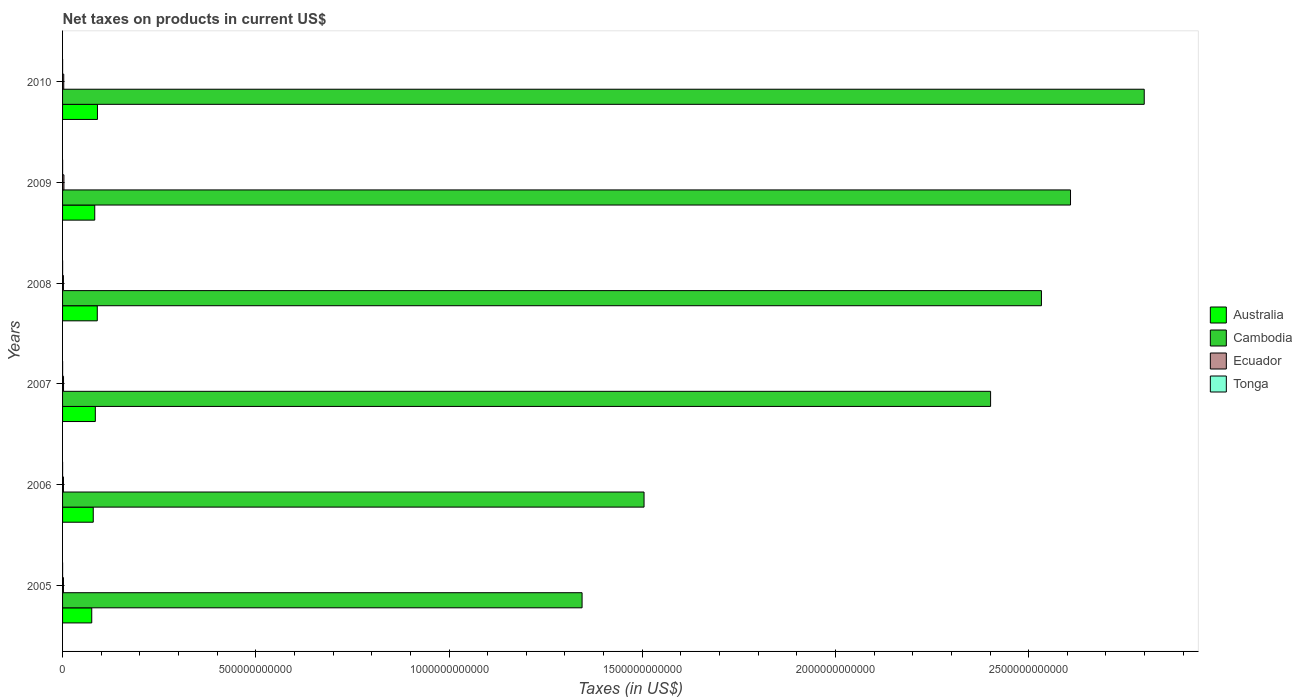How many different coloured bars are there?
Your response must be concise. 4. Are the number of bars per tick equal to the number of legend labels?
Make the answer very short. Yes. Are the number of bars on each tick of the Y-axis equal?
Your answer should be very brief. Yes. What is the label of the 4th group of bars from the top?
Your response must be concise. 2007. In how many cases, is the number of bars for a given year not equal to the number of legend labels?
Your answer should be very brief. 0. What is the net taxes on products in Tonga in 2010?
Keep it short and to the point. 8.43e+07. Across all years, what is the maximum net taxes on products in Tonga?
Give a very brief answer. 1.11e+08. Across all years, what is the minimum net taxes on products in Australia?
Keep it short and to the point. 7.55e+1. In which year was the net taxes on products in Australia maximum?
Your answer should be very brief. 2010. What is the total net taxes on products in Tonga in the graph?
Give a very brief answer. 5.38e+08. What is the difference between the net taxes on products in Ecuador in 2005 and that in 2010?
Provide a short and direct response. -7.54e+08. What is the difference between the net taxes on products in Tonga in 2005 and the net taxes on products in Cambodia in 2008?
Keep it short and to the point. -2.53e+12. What is the average net taxes on products in Tonga per year?
Your answer should be very brief. 8.97e+07. In the year 2009, what is the difference between the net taxes on products in Ecuador and net taxes on products in Tonga?
Make the answer very short. 3.42e+09. In how many years, is the net taxes on products in Tonga greater than 1100000000000 US$?
Your answer should be compact. 0. What is the ratio of the net taxes on products in Ecuador in 2009 to that in 2010?
Your answer should be compact. 1.15. Is the net taxes on products in Australia in 2005 less than that in 2010?
Your response must be concise. Yes. What is the difference between the highest and the second highest net taxes on products in Australia?
Ensure brevity in your answer.  4.98e+08. What is the difference between the highest and the lowest net taxes on products in Australia?
Ensure brevity in your answer.  1.48e+1. Is the sum of the net taxes on products in Australia in 2009 and 2010 greater than the maximum net taxes on products in Tonga across all years?
Keep it short and to the point. Yes. Is it the case that in every year, the sum of the net taxes on products in Cambodia and net taxes on products in Tonga is greater than the sum of net taxes on products in Ecuador and net taxes on products in Australia?
Offer a very short reply. Yes. What does the 2nd bar from the top in 2007 represents?
Make the answer very short. Ecuador. What does the 2nd bar from the bottom in 2008 represents?
Your answer should be compact. Cambodia. How many bars are there?
Your answer should be very brief. 24. Are all the bars in the graph horizontal?
Your answer should be compact. Yes. How many years are there in the graph?
Offer a terse response. 6. What is the difference between two consecutive major ticks on the X-axis?
Offer a very short reply. 5.00e+11. Are the values on the major ticks of X-axis written in scientific E-notation?
Provide a short and direct response. No. Does the graph contain grids?
Your answer should be compact. No. Where does the legend appear in the graph?
Provide a succinct answer. Center right. How are the legend labels stacked?
Keep it short and to the point. Vertical. What is the title of the graph?
Your response must be concise. Net taxes on products in current US$. What is the label or title of the X-axis?
Ensure brevity in your answer.  Taxes (in US$). What is the Taxes (in US$) in Australia in 2005?
Your response must be concise. 7.55e+1. What is the Taxes (in US$) in Cambodia in 2005?
Offer a very short reply. 1.34e+12. What is the Taxes (in US$) in Ecuador in 2005?
Provide a short and direct response. 2.30e+09. What is the Taxes (in US$) of Tonga in 2005?
Your answer should be compact. 7.23e+07. What is the Taxes (in US$) of Australia in 2006?
Offer a terse response. 7.94e+1. What is the Taxes (in US$) in Cambodia in 2006?
Offer a terse response. 1.50e+12. What is the Taxes (in US$) of Ecuador in 2006?
Make the answer very short. 2.30e+09. What is the Taxes (in US$) of Tonga in 2006?
Your response must be concise. 9.02e+07. What is the Taxes (in US$) in Australia in 2007?
Keep it short and to the point. 8.48e+1. What is the Taxes (in US$) in Cambodia in 2007?
Provide a short and direct response. 2.40e+12. What is the Taxes (in US$) of Ecuador in 2007?
Provide a short and direct response. 2.50e+09. What is the Taxes (in US$) of Tonga in 2007?
Ensure brevity in your answer.  9.57e+07. What is the Taxes (in US$) of Australia in 2008?
Provide a succinct answer. 8.98e+1. What is the Taxes (in US$) in Cambodia in 2008?
Make the answer very short. 2.53e+12. What is the Taxes (in US$) of Ecuador in 2008?
Give a very brief answer. 2.21e+09. What is the Taxes (in US$) in Tonga in 2008?
Your response must be concise. 1.11e+08. What is the Taxes (in US$) in Australia in 2009?
Keep it short and to the point. 8.33e+1. What is the Taxes (in US$) in Cambodia in 2009?
Provide a short and direct response. 2.61e+12. What is the Taxes (in US$) of Ecuador in 2009?
Provide a succinct answer. 3.51e+09. What is the Taxes (in US$) of Tonga in 2009?
Keep it short and to the point. 8.51e+07. What is the Taxes (in US$) in Australia in 2010?
Your answer should be very brief. 9.03e+1. What is the Taxes (in US$) of Cambodia in 2010?
Provide a succinct answer. 2.80e+12. What is the Taxes (in US$) in Ecuador in 2010?
Make the answer very short. 3.06e+09. What is the Taxes (in US$) of Tonga in 2010?
Offer a terse response. 8.43e+07. Across all years, what is the maximum Taxes (in US$) of Australia?
Make the answer very short. 9.03e+1. Across all years, what is the maximum Taxes (in US$) of Cambodia?
Provide a succinct answer. 2.80e+12. Across all years, what is the maximum Taxes (in US$) in Ecuador?
Offer a terse response. 3.51e+09. Across all years, what is the maximum Taxes (in US$) of Tonga?
Your answer should be compact. 1.11e+08. Across all years, what is the minimum Taxes (in US$) in Australia?
Your answer should be compact. 7.55e+1. Across all years, what is the minimum Taxes (in US$) in Cambodia?
Keep it short and to the point. 1.34e+12. Across all years, what is the minimum Taxes (in US$) in Ecuador?
Give a very brief answer. 2.21e+09. Across all years, what is the minimum Taxes (in US$) of Tonga?
Offer a very short reply. 7.23e+07. What is the total Taxes (in US$) in Australia in the graph?
Your answer should be very brief. 5.03e+11. What is the total Taxes (in US$) in Cambodia in the graph?
Provide a succinct answer. 1.32e+13. What is the total Taxes (in US$) of Ecuador in the graph?
Your answer should be very brief. 1.59e+1. What is the total Taxes (in US$) of Tonga in the graph?
Provide a succinct answer. 5.38e+08. What is the difference between the Taxes (in US$) of Australia in 2005 and that in 2006?
Your answer should be very brief. -3.87e+09. What is the difference between the Taxes (in US$) in Cambodia in 2005 and that in 2006?
Ensure brevity in your answer.  -1.60e+11. What is the difference between the Taxes (in US$) of Ecuador in 2005 and that in 2006?
Your answer should be compact. -2.96e+06. What is the difference between the Taxes (in US$) of Tonga in 2005 and that in 2006?
Keep it short and to the point. -1.78e+07. What is the difference between the Taxes (in US$) in Australia in 2005 and that in 2007?
Ensure brevity in your answer.  -9.25e+09. What is the difference between the Taxes (in US$) in Cambodia in 2005 and that in 2007?
Give a very brief answer. -1.06e+12. What is the difference between the Taxes (in US$) in Ecuador in 2005 and that in 2007?
Provide a short and direct response. -1.95e+08. What is the difference between the Taxes (in US$) in Tonga in 2005 and that in 2007?
Keep it short and to the point. -2.33e+07. What is the difference between the Taxes (in US$) in Australia in 2005 and that in 2008?
Make the answer very short. -1.43e+1. What is the difference between the Taxes (in US$) in Cambodia in 2005 and that in 2008?
Offer a very short reply. -1.19e+12. What is the difference between the Taxes (in US$) in Ecuador in 2005 and that in 2008?
Keep it short and to the point. 9.02e+07. What is the difference between the Taxes (in US$) in Tonga in 2005 and that in 2008?
Ensure brevity in your answer.  -3.85e+07. What is the difference between the Taxes (in US$) of Australia in 2005 and that in 2009?
Give a very brief answer. -7.77e+09. What is the difference between the Taxes (in US$) of Cambodia in 2005 and that in 2009?
Ensure brevity in your answer.  -1.26e+12. What is the difference between the Taxes (in US$) of Ecuador in 2005 and that in 2009?
Your answer should be compact. -1.20e+09. What is the difference between the Taxes (in US$) of Tonga in 2005 and that in 2009?
Your response must be concise. -1.27e+07. What is the difference between the Taxes (in US$) of Australia in 2005 and that in 2010?
Give a very brief answer. -1.48e+1. What is the difference between the Taxes (in US$) of Cambodia in 2005 and that in 2010?
Your response must be concise. -1.45e+12. What is the difference between the Taxes (in US$) in Ecuador in 2005 and that in 2010?
Provide a short and direct response. -7.54e+08. What is the difference between the Taxes (in US$) of Tonga in 2005 and that in 2010?
Provide a succinct answer. -1.20e+07. What is the difference between the Taxes (in US$) of Australia in 2006 and that in 2007?
Ensure brevity in your answer.  -5.38e+09. What is the difference between the Taxes (in US$) in Cambodia in 2006 and that in 2007?
Offer a terse response. -8.97e+11. What is the difference between the Taxes (in US$) in Ecuador in 2006 and that in 2007?
Keep it short and to the point. -1.92e+08. What is the difference between the Taxes (in US$) of Tonga in 2006 and that in 2007?
Provide a succinct answer. -5.49e+06. What is the difference between the Taxes (in US$) in Australia in 2006 and that in 2008?
Offer a very short reply. -1.04e+1. What is the difference between the Taxes (in US$) in Cambodia in 2006 and that in 2008?
Offer a terse response. -1.03e+12. What is the difference between the Taxes (in US$) of Ecuador in 2006 and that in 2008?
Offer a terse response. 9.32e+07. What is the difference between the Taxes (in US$) of Tonga in 2006 and that in 2008?
Provide a short and direct response. -2.07e+07. What is the difference between the Taxes (in US$) in Australia in 2006 and that in 2009?
Provide a succinct answer. -3.89e+09. What is the difference between the Taxes (in US$) in Cambodia in 2006 and that in 2009?
Ensure brevity in your answer.  -1.10e+12. What is the difference between the Taxes (in US$) in Ecuador in 2006 and that in 2009?
Your response must be concise. -1.20e+09. What is the difference between the Taxes (in US$) in Tonga in 2006 and that in 2009?
Offer a terse response. 5.11e+06. What is the difference between the Taxes (in US$) in Australia in 2006 and that in 2010?
Make the answer very short. -1.09e+1. What is the difference between the Taxes (in US$) in Cambodia in 2006 and that in 2010?
Offer a very short reply. -1.29e+12. What is the difference between the Taxes (in US$) of Ecuador in 2006 and that in 2010?
Your answer should be very brief. -7.51e+08. What is the difference between the Taxes (in US$) in Tonga in 2006 and that in 2010?
Ensure brevity in your answer.  5.81e+06. What is the difference between the Taxes (in US$) of Australia in 2007 and that in 2008?
Provide a succinct answer. -5.06e+09. What is the difference between the Taxes (in US$) in Cambodia in 2007 and that in 2008?
Your answer should be compact. -1.32e+11. What is the difference between the Taxes (in US$) in Ecuador in 2007 and that in 2008?
Offer a terse response. 2.85e+08. What is the difference between the Taxes (in US$) in Tonga in 2007 and that in 2008?
Provide a short and direct response. -1.52e+07. What is the difference between the Taxes (in US$) of Australia in 2007 and that in 2009?
Provide a short and direct response. 1.48e+09. What is the difference between the Taxes (in US$) of Cambodia in 2007 and that in 2009?
Ensure brevity in your answer.  -2.07e+11. What is the difference between the Taxes (in US$) of Ecuador in 2007 and that in 2009?
Your response must be concise. -1.01e+09. What is the difference between the Taxes (in US$) of Tonga in 2007 and that in 2009?
Provide a succinct answer. 1.06e+07. What is the difference between the Taxes (in US$) of Australia in 2007 and that in 2010?
Keep it short and to the point. -5.56e+09. What is the difference between the Taxes (in US$) of Cambodia in 2007 and that in 2010?
Give a very brief answer. -3.98e+11. What is the difference between the Taxes (in US$) in Ecuador in 2007 and that in 2010?
Provide a succinct answer. -5.59e+08. What is the difference between the Taxes (in US$) of Tonga in 2007 and that in 2010?
Offer a terse response. 1.13e+07. What is the difference between the Taxes (in US$) in Australia in 2008 and that in 2009?
Provide a succinct answer. 6.54e+09. What is the difference between the Taxes (in US$) of Cambodia in 2008 and that in 2009?
Make the answer very short. -7.53e+1. What is the difference between the Taxes (in US$) in Ecuador in 2008 and that in 2009?
Provide a short and direct response. -1.29e+09. What is the difference between the Taxes (in US$) in Tonga in 2008 and that in 2009?
Keep it short and to the point. 2.58e+07. What is the difference between the Taxes (in US$) of Australia in 2008 and that in 2010?
Give a very brief answer. -4.98e+08. What is the difference between the Taxes (in US$) of Cambodia in 2008 and that in 2010?
Your response must be concise. -2.66e+11. What is the difference between the Taxes (in US$) of Ecuador in 2008 and that in 2010?
Offer a very short reply. -8.44e+08. What is the difference between the Taxes (in US$) in Tonga in 2008 and that in 2010?
Provide a succinct answer. 2.65e+07. What is the difference between the Taxes (in US$) of Australia in 2009 and that in 2010?
Your answer should be very brief. -7.04e+09. What is the difference between the Taxes (in US$) in Cambodia in 2009 and that in 2010?
Provide a short and direct response. -1.91e+11. What is the difference between the Taxes (in US$) in Ecuador in 2009 and that in 2010?
Your answer should be compact. 4.51e+08. What is the difference between the Taxes (in US$) of Tonga in 2009 and that in 2010?
Keep it short and to the point. 7.02e+05. What is the difference between the Taxes (in US$) in Australia in 2005 and the Taxes (in US$) in Cambodia in 2006?
Your answer should be compact. -1.43e+12. What is the difference between the Taxes (in US$) in Australia in 2005 and the Taxes (in US$) in Ecuador in 2006?
Your answer should be compact. 7.32e+1. What is the difference between the Taxes (in US$) in Australia in 2005 and the Taxes (in US$) in Tonga in 2006?
Provide a succinct answer. 7.54e+1. What is the difference between the Taxes (in US$) of Cambodia in 2005 and the Taxes (in US$) of Ecuador in 2006?
Make the answer very short. 1.34e+12. What is the difference between the Taxes (in US$) of Cambodia in 2005 and the Taxes (in US$) of Tonga in 2006?
Ensure brevity in your answer.  1.34e+12. What is the difference between the Taxes (in US$) of Ecuador in 2005 and the Taxes (in US$) of Tonga in 2006?
Make the answer very short. 2.21e+09. What is the difference between the Taxes (in US$) of Australia in 2005 and the Taxes (in US$) of Cambodia in 2007?
Your answer should be compact. -2.33e+12. What is the difference between the Taxes (in US$) of Australia in 2005 and the Taxes (in US$) of Ecuador in 2007?
Your answer should be compact. 7.30e+1. What is the difference between the Taxes (in US$) in Australia in 2005 and the Taxes (in US$) in Tonga in 2007?
Your response must be concise. 7.54e+1. What is the difference between the Taxes (in US$) in Cambodia in 2005 and the Taxes (in US$) in Ecuador in 2007?
Ensure brevity in your answer.  1.34e+12. What is the difference between the Taxes (in US$) in Cambodia in 2005 and the Taxes (in US$) in Tonga in 2007?
Offer a very short reply. 1.34e+12. What is the difference between the Taxes (in US$) in Ecuador in 2005 and the Taxes (in US$) in Tonga in 2007?
Offer a very short reply. 2.21e+09. What is the difference between the Taxes (in US$) in Australia in 2005 and the Taxes (in US$) in Cambodia in 2008?
Your answer should be compact. -2.46e+12. What is the difference between the Taxes (in US$) of Australia in 2005 and the Taxes (in US$) of Ecuador in 2008?
Your response must be concise. 7.33e+1. What is the difference between the Taxes (in US$) in Australia in 2005 and the Taxes (in US$) in Tonga in 2008?
Ensure brevity in your answer.  7.54e+1. What is the difference between the Taxes (in US$) of Cambodia in 2005 and the Taxes (in US$) of Ecuador in 2008?
Offer a terse response. 1.34e+12. What is the difference between the Taxes (in US$) of Cambodia in 2005 and the Taxes (in US$) of Tonga in 2008?
Offer a terse response. 1.34e+12. What is the difference between the Taxes (in US$) in Ecuador in 2005 and the Taxes (in US$) in Tonga in 2008?
Provide a short and direct response. 2.19e+09. What is the difference between the Taxes (in US$) in Australia in 2005 and the Taxes (in US$) in Cambodia in 2009?
Give a very brief answer. -2.53e+12. What is the difference between the Taxes (in US$) of Australia in 2005 and the Taxes (in US$) of Ecuador in 2009?
Provide a short and direct response. 7.20e+1. What is the difference between the Taxes (in US$) in Australia in 2005 and the Taxes (in US$) in Tonga in 2009?
Your answer should be compact. 7.54e+1. What is the difference between the Taxes (in US$) of Cambodia in 2005 and the Taxes (in US$) of Ecuador in 2009?
Keep it short and to the point. 1.34e+12. What is the difference between the Taxes (in US$) in Cambodia in 2005 and the Taxes (in US$) in Tonga in 2009?
Your answer should be compact. 1.34e+12. What is the difference between the Taxes (in US$) of Ecuador in 2005 and the Taxes (in US$) of Tonga in 2009?
Provide a short and direct response. 2.22e+09. What is the difference between the Taxes (in US$) in Australia in 2005 and the Taxes (in US$) in Cambodia in 2010?
Give a very brief answer. -2.72e+12. What is the difference between the Taxes (in US$) in Australia in 2005 and the Taxes (in US$) in Ecuador in 2010?
Provide a short and direct response. 7.25e+1. What is the difference between the Taxes (in US$) in Australia in 2005 and the Taxes (in US$) in Tonga in 2010?
Your answer should be very brief. 7.54e+1. What is the difference between the Taxes (in US$) in Cambodia in 2005 and the Taxes (in US$) in Ecuador in 2010?
Your answer should be compact. 1.34e+12. What is the difference between the Taxes (in US$) in Cambodia in 2005 and the Taxes (in US$) in Tonga in 2010?
Your answer should be very brief. 1.34e+12. What is the difference between the Taxes (in US$) of Ecuador in 2005 and the Taxes (in US$) of Tonga in 2010?
Your answer should be very brief. 2.22e+09. What is the difference between the Taxes (in US$) in Australia in 2006 and the Taxes (in US$) in Cambodia in 2007?
Ensure brevity in your answer.  -2.32e+12. What is the difference between the Taxes (in US$) of Australia in 2006 and the Taxes (in US$) of Ecuador in 2007?
Ensure brevity in your answer.  7.69e+1. What is the difference between the Taxes (in US$) in Australia in 2006 and the Taxes (in US$) in Tonga in 2007?
Provide a short and direct response. 7.93e+1. What is the difference between the Taxes (in US$) of Cambodia in 2006 and the Taxes (in US$) of Ecuador in 2007?
Keep it short and to the point. 1.50e+12. What is the difference between the Taxes (in US$) in Cambodia in 2006 and the Taxes (in US$) in Tonga in 2007?
Your answer should be compact. 1.50e+12. What is the difference between the Taxes (in US$) of Ecuador in 2006 and the Taxes (in US$) of Tonga in 2007?
Offer a very short reply. 2.21e+09. What is the difference between the Taxes (in US$) of Australia in 2006 and the Taxes (in US$) of Cambodia in 2008?
Your answer should be compact. -2.45e+12. What is the difference between the Taxes (in US$) of Australia in 2006 and the Taxes (in US$) of Ecuador in 2008?
Offer a very short reply. 7.72e+1. What is the difference between the Taxes (in US$) of Australia in 2006 and the Taxes (in US$) of Tonga in 2008?
Give a very brief answer. 7.93e+1. What is the difference between the Taxes (in US$) in Cambodia in 2006 and the Taxes (in US$) in Ecuador in 2008?
Your answer should be very brief. 1.50e+12. What is the difference between the Taxes (in US$) of Cambodia in 2006 and the Taxes (in US$) of Tonga in 2008?
Your answer should be very brief. 1.50e+12. What is the difference between the Taxes (in US$) of Ecuador in 2006 and the Taxes (in US$) of Tonga in 2008?
Provide a succinct answer. 2.19e+09. What is the difference between the Taxes (in US$) in Australia in 2006 and the Taxes (in US$) in Cambodia in 2009?
Give a very brief answer. -2.53e+12. What is the difference between the Taxes (in US$) of Australia in 2006 and the Taxes (in US$) of Ecuador in 2009?
Provide a succinct answer. 7.59e+1. What is the difference between the Taxes (in US$) of Australia in 2006 and the Taxes (in US$) of Tonga in 2009?
Keep it short and to the point. 7.93e+1. What is the difference between the Taxes (in US$) of Cambodia in 2006 and the Taxes (in US$) of Ecuador in 2009?
Ensure brevity in your answer.  1.50e+12. What is the difference between the Taxes (in US$) of Cambodia in 2006 and the Taxes (in US$) of Tonga in 2009?
Offer a terse response. 1.50e+12. What is the difference between the Taxes (in US$) of Ecuador in 2006 and the Taxes (in US$) of Tonga in 2009?
Give a very brief answer. 2.22e+09. What is the difference between the Taxes (in US$) of Australia in 2006 and the Taxes (in US$) of Cambodia in 2010?
Offer a very short reply. -2.72e+12. What is the difference between the Taxes (in US$) of Australia in 2006 and the Taxes (in US$) of Ecuador in 2010?
Keep it short and to the point. 7.63e+1. What is the difference between the Taxes (in US$) of Australia in 2006 and the Taxes (in US$) of Tonga in 2010?
Provide a succinct answer. 7.93e+1. What is the difference between the Taxes (in US$) of Cambodia in 2006 and the Taxes (in US$) of Ecuador in 2010?
Your answer should be very brief. 1.50e+12. What is the difference between the Taxes (in US$) in Cambodia in 2006 and the Taxes (in US$) in Tonga in 2010?
Provide a short and direct response. 1.50e+12. What is the difference between the Taxes (in US$) in Ecuador in 2006 and the Taxes (in US$) in Tonga in 2010?
Your response must be concise. 2.22e+09. What is the difference between the Taxes (in US$) in Australia in 2007 and the Taxes (in US$) in Cambodia in 2008?
Keep it short and to the point. -2.45e+12. What is the difference between the Taxes (in US$) of Australia in 2007 and the Taxes (in US$) of Ecuador in 2008?
Your answer should be compact. 8.26e+1. What is the difference between the Taxes (in US$) of Australia in 2007 and the Taxes (in US$) of Tonga in 2008?
Make the answer very short. 8.47e+1. What is the difference between the Taxes (in US$) of Cambodia in 2007 and the Taxes (in US$) of Ecuador in 2008?
Give a very brief answer. 2.40e+12. What is the difference between the Taxes (in US$) in Cambodia in 2007 and the Taxes (in US$) in Tonga in 2008?
Give a very brief answer. 2.40e+12. What is the difference between the Taxes (in US$) in Ecuador in 2007 and the Taxes (in US$) in Tonga in 2008?
Give a very brief answer. 2.39e+09. What is the difference between the Taxes (in US$) of Australia in 2007 and the Taxes (in US$) of Cambodia in 2009?
Ensure brevity in your answer.  -2.52e+12. What is the difference between the Taxes (in US$) of Australia in 2007 and the Taxes (in US$) of Ecuador in 2009?
Ensure brevity in your answer.  8.13e+1. What is the difference between the Taxes (in US$) in Australia in 2007 and the Taxes (in US$) in Tonga in 2009?
Offer a very short reply. 8.47e+1. What is the difference between the Taxes (in US$) of Cambodia in 2007 and the Taxes (in US$) of Ecuador in 2009?
Keep it short and to the point. 2.40e+12. What is the difference between the Taxes (in US$) in Cambodia in 2007 and the Taxes (in US$) in Tonga in 2009?
Your answer should be compact. 2.40e+12. What is the difference between the Taxes (in US$) of Ecuador in 2007 and the Taxes (in US$) of Tonga in 2009?
Offer a very short reply. 2.41e+09. What is the difference between the Taxes (in US$) in Australia in 2007 and the Taxes (in US$) in Cambodia in 2010?
Your response must be concise. -2.71e+12. What is the difference between the Taxes (in US$) of Australia in 2007 and the Taxes (in US$) of Ecuador in 2010?
Keep it short and to the point. 8.17e+1. What is the difference between the Taxes (in US$) of Australia in 2007 and the Taxes (in US$) of Tonga in 2010?
Keep it short and to the point. 8.47e+1. What is the difference between the Taxes (in US$) of Cambodia in 2007 and the Taxes (in US$) of Ecuador in 2010?
Provide a short and direct response. 2.40e+12. What is the difference between the Taxes (in US$) of Cambodia in 2007 and the Taxes (in US$) of Tonga in 2010?
Your response must be concise. 2.40e+12. What is the difference between the Taxes (in US$) in Ecuador in 2007 and the Taxes (in US$) in Tonga in 2010?
Keep it short and to the point. 2.41e+09. What is the difference between the Taxes (in US$) of Australia in 2008 and the Taxes (in US$) of Cambodia in 2009?
Offer a terse response. -2.52e+12. What is the difference between the Taxes (in US$) in Australia in 2008 and the Taxes (in US$) in Ecuador in 2009?
Offer a very short reply. 8.63e+1. What is the difference between the Taxes (in US$) in Australia in 2008 and the Taxes (in US$) in Tonga in 2009?
Your answer should be very brief. 8.98e+1. What is the difference between the Taxes (in US$) in Cambodia in 2008 and the Taxes (in US$) in Ecuador in 2009?
Your answer should be compact. 2.53e+12. What is the difference between the Taxes (in US$) of Cambodia in 2008 and the Taxes (in US$) of Tonga in 2009?
Your answer should be very brief. 2.53e+12. What is the difference between the Taxes (in US$) in Ecuador in 2008 and the Taxes (in US$) in Tonga in 2009?
Offer a terse response. 2.13e+09. What is the difference between the Taxes (in US$) in Australia in 2008 and the Taxes (in US$) in Cambodia in 2010?
Provide a short and direct response. -2.71e+12. What is the difference between the Taxes (in US$) of Australia in 2008 and the Taxes (in US$) of Ecuador in 2010?
Offer a terse response. 8.68e+1. What is the difference between the Taxes (in US$) in Australia in 2008 and the Taxes (in US$) in Tonga in 2010?
Ensure brevity in your answer.  8.98e+1. What is the difference between the Taxes (in US$) of Cambodia in 2008 and the Taxes (in US$) of Ecuador in 2010?
Your response must be concise. 2.53e+12. What is the difference between the Taxes (in US$) in Cambodia in 2008 and the Taxes (in US$) in Tonga in 2010?
Provide a succinct answer. 2.53e+12. What is the difference between the Taxes (in US$) of Ecuador in 2008 and the Taxes (in US$) of Tonga in 2010?
Provide a succinct answer. 2.13e+09. What is the difference between the Taxes (in US$) of Australia in 2009 and the Taxes (in US$) of Cambodia in 2010?
Keep it short and to the point. -2.72e+12. What is the difference between the Taxes (in US$) of Australia in 2009 and the Taxes (in US$) of Ecuador in 2010?
Provide a short and direct response. 8.02e+1. What is the difference between the Taxes (in US$) in Australia in 2009 and the Taxes (in US$) in Tonga in 2010?
Provide a succinct answer. 8.32e+1. What is the difference between the Taxes (in US$) in Cambodia in 2009 and the Taxes (in US$) in Ecuador in 2010?
Offer a very short reply. 2.61e+12. What is the difference between the Taxes (in US$) in Cambodia in 2009 and the Taxes (in US$) in Tonga in 2010?
Provide a succinct answer. 2.61e+12. What is the difference between the Taxes (in US$) in Ecuador in 2009 and the Taxes (in US$) in Tonga in 2010?
Provide a succinct answer. 3.42e+09. What is the average Taxes (in US$) of Australia per year?
Provide a short and direct response. 8.39e+1. What is the average Taxes (in US$) in Cambodia per year?
Offer a terse response. 2.20e+12. What is the average Taxes (in US$) in Ecuador per year?
Provide a succinct answer. 2.65e+09. What is the average Taxes (in US$) of Tonga per year?
Provide a succinct answer. 8.97e+07. In the year 2005, what is the difference between the Taxes (in US$) in Australia and Taxes (in US$) in Cambodia?
Keep it short and to the point. -1.27e+12. In the year 2005, what is the difference between the Taxes (in US$) of Australia and Taxes (in US$) of Ecuador?
Your response must be concise. 7.32e+1. In the year 2005, what is the difference between the Taxes (in US$) of Australia and Taxes (in US$) of Tonga?
Provide a short and direct response. 7.55e+1. In the year 2005, what is the difference between the Taxes (in US$) of Cambodia and Taxes (in US$) of Ecuador?
Provide a succinct answer. 1.34e+12. In the year 2005, what is the difference between the Taxes (in US$) of Cambodia and Taxes (in US$) of Tonga?
Your answer should be very brief. 1.34e+12. In the year 2005, what is the difference between the Taxes (in US$) in Ecuador and Taxes (in US$) in Tonga?
Provide a short and direct response. 2.23e+09. In the year 2006, what is the difference between the Taxes (in US$) of Australia and Taxes (in US$) of Cambodia?
Provide a succinct answer. -1.43e+12. In the year 2006, what is the difference between the Taxes (in US$) of Australia and Taxes (in US$) of Ecuador?
Provide a succinct answer. 7.71e+1. In the year 2006, what is the difference between the Taxes (in US$) in Australia and Taxes (in US$) in Tonga?
Give a very brief answer. 7.93e+1. In the year 2006, what is the difference between the Taxes (in US$) in Cambodia and Taxes (in US$) in Ecuador?
Provide a short and direct response. 1.50e+12. In the year 2006, what is the difference between the Taxes (in US$) in Cambodia and Taxes (in US$) in Tonga?
Offer a very short reply. 1.50e+12. In the year 2006, what is the difference between the Taxes (in US$) of Ecuador and Taxes (in US$) of Tonga?
Ensure brevity in your answer.  2.21e+09. In the year 2007, what is the difference between the Taxes (in US$) of Australia and Taxes (in US$) of Cambodia?
Your response must be concise. -2.32e+12. In the year 2007, what is the difference between the Taxes (in US$) of Australia and Taxes (in US$) of Ecuador?
Give a very brief answer. 8.23e+1. In the year 2007, what is the difference between the Taxes (in US$) in Australia and Taxes (in US$) in Tonga?
Your answer should be compact. 8.47e+1. In the year 2007, what is the difference between the Taxes (in US$) in Cambodia and Taxes (in US$) in Ecuador?
Your answer should be compact. 2.40e+12. In the year 2007, what is the difference between the Taxes (in US$) of Cambodia and Taxes (in US$) of Tonga?
Give a very brief answer. 2.40e+12. In the year 2007, what is the difference between the Taxes (in US$) of Ecuador and Taxes (in US$) of Tonga?
Give a very brief answer. 2.40e+09. In the year 2008, what is the difference between the Taxes (in US$) in Australia and Taxes (in US$) in Cambodia?
Give a very brief answer. -2.44e+12. In the year 2008, what is the difference between the Taxes (in US$) of Australia and Taxes (in US$) of Ecuador?
Your answer should be compact. 8.76e+1. In the year 2008, what is the difference between the Taxes (in US$) in Australia and Taxes (in US$) in Tonga?
Your answer should be compact. 8.97e+1. In the year 2008, what is the difference between the Taxes (in US$) in Cambodia and Taxes (in US$) in Ecuador?
Offer a very short reply. 2.53e+12. In the year 2008, what is the difference between the Taxes (in US$) of Cambodia and Taxes (in US$) of Tonga?
Make the answer very short. 2.53e+12. In the year 2008, what is the difference between the Taxes (in US$) in Ecuador and Taxes (in US$) in Tonga?
Give a very brief answer. 2.10e+09. In the year 2009, what is the difference between the Taxes (in US$) in Australia and Taxes (in US$) in Cambodia?
Your answer should be compact. -2.52e+12. In the year 2009, what is the difference between the Taxes (in US$) in Australia and Taxes (in US$) in Ecuador?
Keep it short and to the point. 7.98e+1. In the year 2009, what is the difference between the Taxes (in US$) in Australia and Taxes (in US$) in Tonga?
Offer a terse response. 8.32e+1. In the year 2009, what is the difference between the Taxes (in US$) in Cambodia and Taxes (in US$) in Ecuador?
Give a very brief answer. 2.60e+12. In the year 2009, what is the difference between the Taxes (in US$) of Cambodia and Taxes (in US$) of Tonga?
Give a very brief answer. 2.61e+12. In the year 2009, what is the difference between the Taxes (in US$) in Ecuador and Taxes (in US$) in Tonga?
Provide a short and direct response. 3.42e+09. In the year 2010, what is the difference between the Taxes (in US$) in Australia and Taxes (in US$) in Cambodia?
Provide a succinct answer. -2.71e+12. In the year 2010, what is the difference between the Taxes (in US$) in Australia and Taxes (in US$) in Ecuador?
Provide a succinct answer. 8.73e+1. In the year 2010, what is the difference between the Taxes (in US$) in Australia and Taxes (in US$) in Tonga?
Provide a short and direct response. 9.03e+1. In the year 2010, what is the difference between the Taxes (in US$) in Cambodia and Taxes (in US$) in Ecuador?
Ensure brevity in your answer.  2.80e+12. In the year 2010, what is the difference between the Taxes (in US$) of Cambodia and Taxes (in US$) of Tonga?
Give a very brief answer. 2.80e+12. In the year 2010, what is the difference between the Taxes (in US$) in Ecuador and Taxes (in US$) in Tonga?
Provide a succinct answer. 2.97e+09. What is the ratio of the Taxes (in US$) of Australia in 2005 to that in 2006?
Offer a terse response. 0.95. What is the ratio of the Taxes (in US$) in Cambodia in 2005 to that in 2006?
Make the answer very short. 0.89. What is the ratio of the Taxes (in US$) in Tonga in 2005 to that in 2006?
Offer a very short reply. 0.8. What is the ratio of the Taxes (in US$) of Australia in 2005 to that in 2007?
Your answer should be very brief. 0.89. What is the ratio of the Taxes (in US$) of Cambodia in 2005 to that in 2007?
Offer a very short reply. 0.56. What is the ratio of the Taxes (in US$) in Ecuador in 2005 to that in 2007?
Your answer should be very brief. 0.92. What is the ratio of the Taxes (in US$) of Tonga in 2005 to that in 2007?
Provide a succinct answer. 0.76. What is the ratio of the Taxes (in US$) of Australia in 2005 to that in 2008?
Offer a very short reply. 0.84. What is the ratio of the Taxes (in US$) of Cambodia in 2005 to that in 2008?
Your answer should be compact. 0.53. What is the ratio of the Taxes (in US$) in Ecuador in 2005 to that in 2008?
Your response must be concise. 1.04. What is the ratio of the Taxes (in US$) of Tonga in 2005 to that in 2008?
Give a very brief answer. 0.65. What is the ratio of the Taxes (in US$) of Australia in 2005 to that in 2009?
Provide a short and direct response. 0.91. What is the ratio of the Taxes (in US$) of Cambodia in 2005 to that in 2009?
Provide a short and direct response. 0.52. What is the ratio of the Taxes (in US$) in Ecuador in 2005 to that in 2009?
Provide a short and direct response. 0.66. What is the ratio of the Taxes (in US$) in Tonga in 2005 to that in 2009?
Your response must be concise. 0.85. What is the ratio of the Taxes (in US$) in Australia in 2005 to that in 2010?
Offer a very short reply. 0.84. What is the ratio of the Taxes (in US$) in Cambodia in 2005 to that in 2010?
Your answer should be compact. 0.48. What is the ratio of the Taxes (in US$) of Ecuador in 2005 to that in 2010?
Keep it short and to the point. 0.75. What is the ratio of the Taxes (in US$) of Tonga in 2005 to that in 2010?
Make the answer very short. 0.86. What is the ratio of the Taxes (in US$) in Australia in 2006 to that in 2007?
Your answer should be compact. 0.94. What is the ratio of the Taxes (in US$) of Cambodia in 2006 to that in 2007?
Your response must be concise. 0.63. What is the ratio of the Taxes (in US$) in Tonga in 2006 to that in 2007?
Ensure brevity in your answer.  0.94. What is the ratio of the Taxes (in US$) in Australia in 2006 to that in 2008?
Your answer should be very brief. 0.88. What is the ratio of the Taxes (in US$) in Cambodia in 2006 to that in 2008?
Ensure brevity in your answer.  0.59. What is the ratio of the Taxes (in US$) in Ecuador in 2006 to that in 2008?
Provide a short and direct response. 1.04. What is the ratio of the Taxes (in US$) in Tonga in 2006 to that in 2008?
Ensure brevity in your answer.  0.81. What is the ratio of the Taxes (in US$) of Australia in 2006 to that in 2009?
Make the answer very short. 0.95. What is the ratio of the Taxes (in US$) of Cambodia in 2006 to that in 2009?
Offer a very short reply. 0.58. What is the ratio of the Taxes (in US$) of Ecuador in 2006 to that in 2009?
Your answer should be compact. 0.66. What is the ratio of the Taxes (in US$) in Tonga in 2006 to that in 2009?
Your answer should be very brief. 1.06. What is the ratio of the Taxes (in US$) of Australia in 2006 to that in 2010?
Provide a succinct answer. 0.88. What is the ratio of the Taxes (in US$) in Cambodia in 2006 to that in 2010?
Provide a succinct answer. 0.54. What is the ratio of the Taxes (in US$) of Ecuador in 2006 to that in 2010?
Offer a terse response. 0.75. What is the ratio of the Taxes (in US$) in Tonga in 2006 to that in 2010?
Your response must be concise. 1.07. What is the ratio of the Taxes (in US$) in Australia in 2007 to that in 2008?
Your response must be concise. 0.94. What is the ratio of the Taxes (in US$) of Cambodia in 2007 to that in 2008?
Give a very brief answer. 0.95. What is the ratio of the Taxes (in US$) of Ecuador in 2007 to that in 2008?
Keep it short and to the point. 1.13. What is the ratio of the Taxes (in US$) in Tonga in 2007 to that in 2008?
Give a very brief answer. 0.86. What is the ratio of the Taxes (in US$) of Australia in 2007 to that in 2009?
Offer a very short reply. 1.02. What is the ratio of the Taxes (in US$) of Cambodia in 2007 to that in 2009?
Provide a succinct answer. 0.92. What is the ratio of the Taxes (in US$) in Ecuador in 2007 to that in 2009?
Your answer should be very brief. 0.71. What is the ratio of the Taxes (in US$) in Tonga in 2007 to that in 2009?
Provide a short and direct response. 1.12. What is the ratio of the Taxes (in US$) of Australia in 2007 to that in 2010?
Provide a short and direct response. 0.94. What is the ratio of the Taxes (in US$) of Cambodia in 2007 to that in 2010?
Offer a very short reply. 0.86. What is the ratio of the Taxes (in US$) of Ecuador in 2007 to that in 2010?
Provide a short and direct response. 0.82. What is the ratio of the Taxes (in US$) in Tonga in 2007 to that in 2010?
Provide a succinct answer. 1.13. What is the ratio of the Taxes (in US$) of Australia in 2008 to that in 2009?
Keep it short and to the point. 1.08. What is the ratio of the Taxes (in US$) in Cambodia in 2008 to that in 2009?
Provide a short and direct response. 0.97. What is the ratio of the Taxes (in US$) in Ecuador in 2008 to that in 2009?
Offer a terse response. 0.63. What is the ratio of the Taxes (in US$) in Tonga in 2008 to that in 2009?
Your response must be concise. 1.3. What is the ratio of the Taxes (in US$) in Australia in 2008 to that in 2010?
Offer a very short reply. 0.99. What is the ratio of the Taxes (in US$) in Cambodia in 2008 to that in 2010?
Keep it short and to the point. 0.91. What is the ratio of the Taxes (in US$) in Ecuador in 2008 to that in 2010?
Keep it short and to the point. 0.72. What is the ratio of the Taxes (in US$) in Tonga in 2008 to that in 2010?
Your response must be concise. 1.31. What is the ratio of the Taxes (in US$) in Australia in 2009 to that in 2010?
Your answer should be very brief. 0.92. What is the ratio of the Taxes (in US$) of Cambodia in 2009 to that in 2010?
Your response must be concise. 0.93. What is the ratio of the Taxes (in US$) of Ecuador in 2009 to that in 2010?
Keep it short and to the point. 1.15. What is the ratio of the Taxes (in US$) in Tonga in 2009 to that in 2010?
Give a very brief answer. 1.01. What is the difference between the highest and the second highest Taxes (in US$) of Australia?
Your answer should be compact. 4.98e+08. What is the difference between the highest and the second highest Taxes (in US$) in Cambodia?
Provide a succinct answer. 1.91e+11. What is the difference between the highest and the second highest Taxes (in US$) in Ecuador?
Offer a very short reply. 4.51e+08. What is the difference between the highest and the second highest Taxes (in US$) in Tonga?
Your answer should be compact. 1.52e+07. What is the difference between the highest and the lowest Taxes (in US$) of Australia?
Ensure brevity in your answer.  1.48e+1. What is the difference between the highest and the lowest Taxes (in US$) of Cambodia?
Provide a succinct answer. 1.45e+12. What is the difference between the highest and the lowest Taxes (in US$) of Ecuador?
Your response must be concise. 1.29e+09. What is the difference between the highest and the lowest Taxes (in US$) of Tonga?
Your answer should be compact. 3.85e+07. 